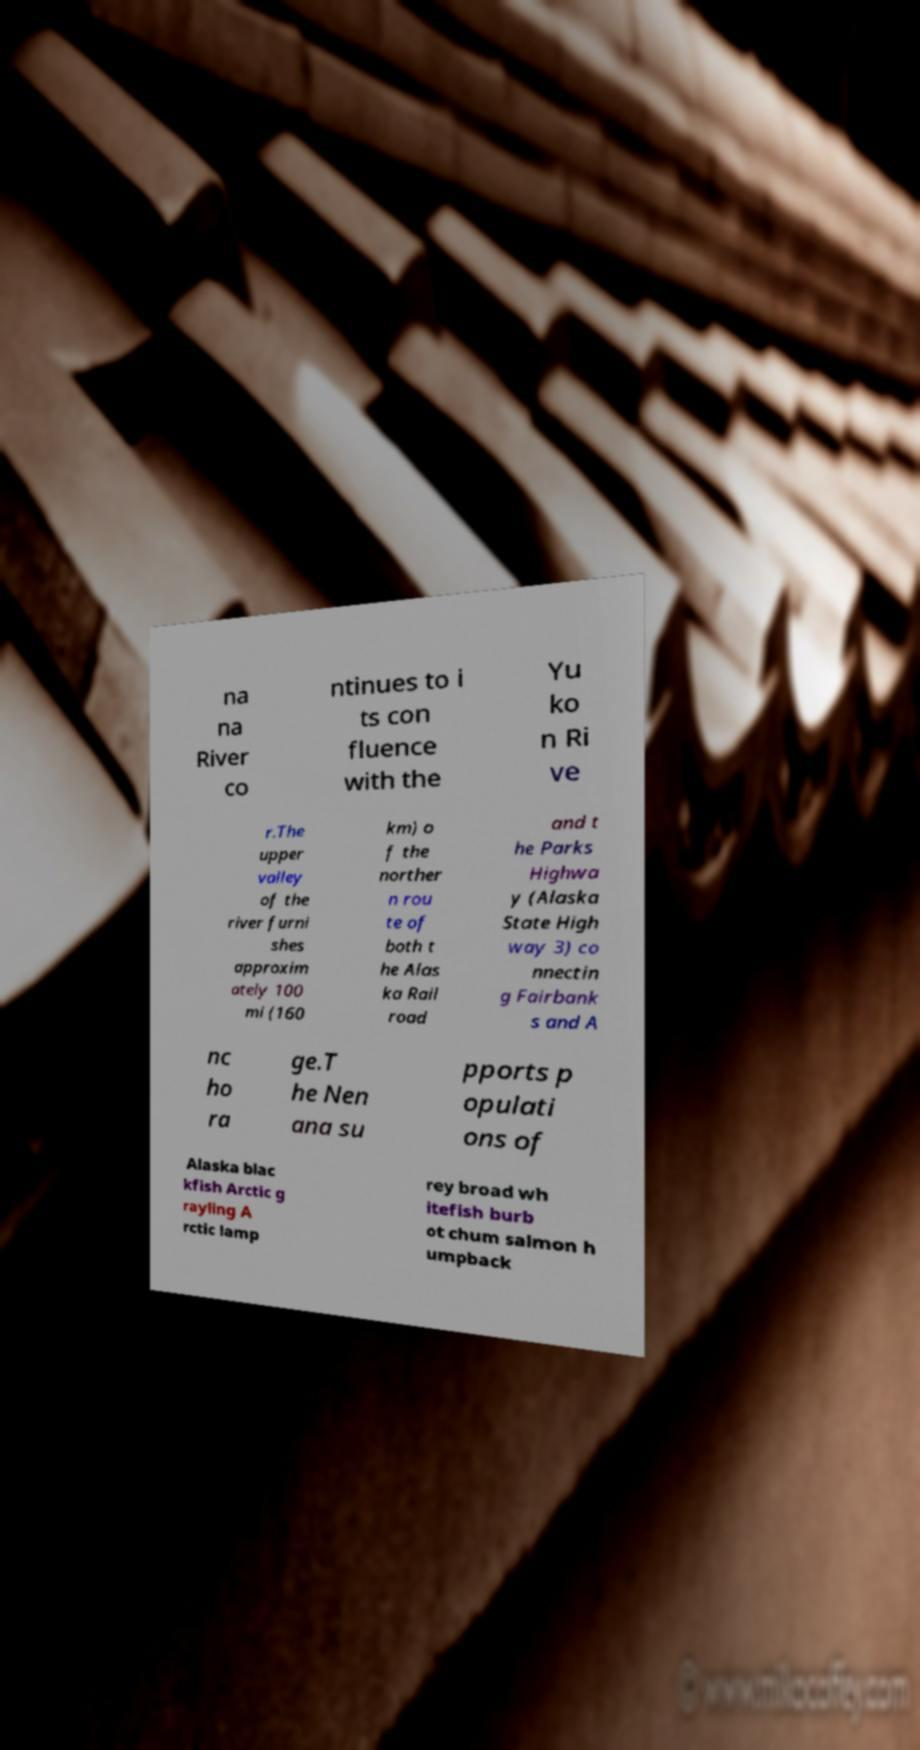What messages or text are displayed in this image? I need them in a readable, typed format. na na River co ntinues to i ts con fluence with the Yu ko n Ri ve r.The upper valley of the river furni shes approxim ately 100 mi (160 km) o f the norther n rou te of both t he Alas ka Rail road and t he Parks Highwa y (Alaska State High way 3) co nnectin g Fairbank s and A nc ho ra ge.T he Nen ana su pports p opulati ons of Alaska blac kfish Arctic g rayling A rctic lamp rey broad wh itefish burb ot chum salmon h umpback 